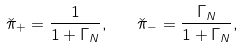Convert formula to latex. <formula><loc_0><loc_0><loc_500><loc_500>\check { \pi } _ { + } = \frac { 1 } { 1 + \Gamma _ { N } } , \quad \check { \pi } _ { - } = \frac { \Gamma _ { N } } { 1 + \Gamma _ { N } } ,</formula> 